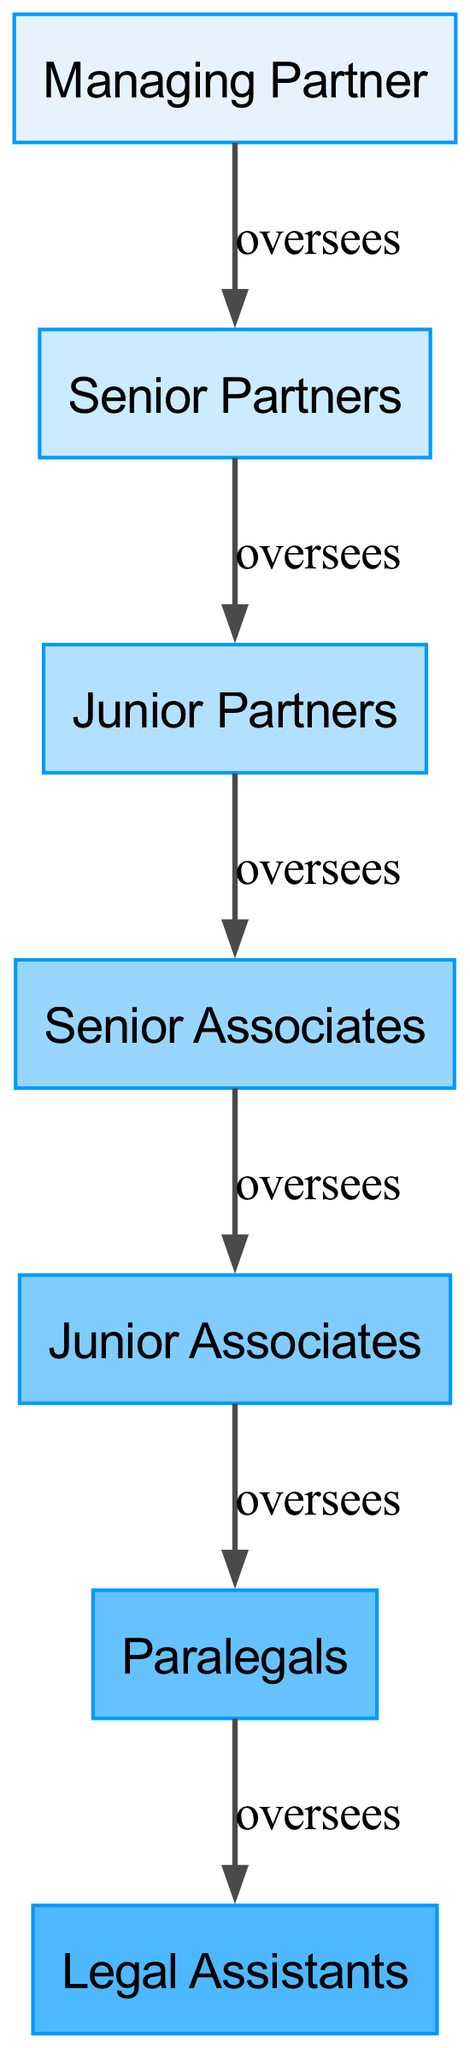What is the top position in the hierarchy? The diagram indicates that the highest position is occupied by the "Managing Partner." No other roles are above this title as it is the starting point of the hierarchy.
Answer: Managing Partner How many total roles are there in the hierarchy? Counting the distinct roles listed in the diagram, there are seven positions: Managing Partner, Senior Partners, Junior Partners, Senior Associates, Junior Associates, Paralegals, and Legal Assistants.
Answer: 7 Which role oversees the Junior Associates? The diagram shows that "Junior Partners" are the ones who oversee the "Senior Associates," who in turn oversee the "Junior Associates." Therefore, tracing upward, the supervision is from Junior Partners to Senior Associates to Junior Associates.
Answer: Junior Partners Which position has no subordinates? The "Legal Assistants" are the final role in the hierarchy as they do not oversee any other positions, indicating they have no subordinates.
Answer: Legal Assistants How are Senior Partners related to the Managing Partner? The "Managing Partner" is at the top of the hierarchy and oversees "Senior Partners," making the relationship a supervisory one where the Managing Partner has authority over Senior Partners.
Answer: oversees What is the bottom role in the food chain of the law firm? The last position in this hierarchy is "Legal Assistants," as they do not have anyone beneath them in the diagram.
Answer: Legal Assistants Which position is directly above Junior Associates? According to the hierarchy, the "Senior Associates" are directly above "Junior Associates," indicating a direct supervisory relationship.
Answer: Senior Associates What is the relationship between Junior Partners and Senior Associates? In the diagram, Junior Partners directly oversee Senior Associates, forming a chain where Junior Partners have authority over Senior Associates.
Answer: oversees 